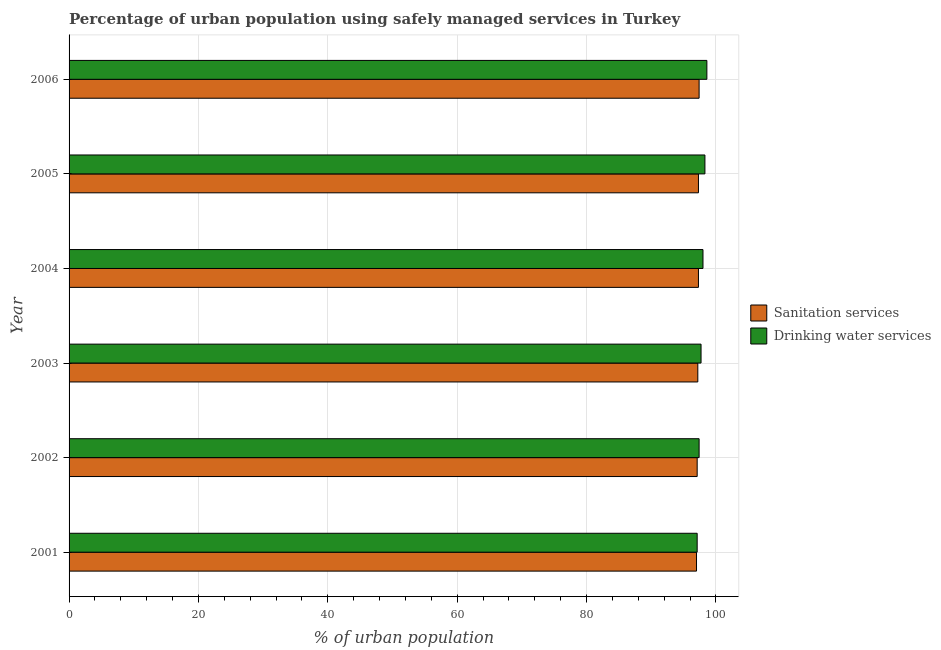How many groups of bars are there?
Offer a very short reply. 6. Are the number of bars on each tick of the Y-axis equal?
Provide a short and direct response. Yes. How many bars are there on the 3rd tick from the top?
Your response must be concise. 2. How many bars are there on the 1st tick from the bottom?
Your answer should be very brief. 2. What is the percentage of urban population who used sanitation services in 2003?
Offer a very short reply. 97.2. Across all years, what is the maximum percentage of urban population who used drinking water services?
Provide a short and direct response. 98.6. Across all years, what is the minimum percentage of urban population who used drinking water services?
Offer a very short reply. 97.1. In which year was the percentage of urban population who used drinking water services maximum?
Provide a short and direct response. 2006. What is the total percentage of urban population who used sanitation services in the graph?
Your response must be concise. 583.3. What is the difference between the percentage of urban population who used drinking water services in 2004 and the percentage of urban population who used sanitation services in 2005?
Provide a short and direct response. 0.7. What is the average percentage of urban population who used sanitation services per year?
Your answer should be very brief. 97.22. In the year 2005, what is the difference between the percentage of urban population who used drinking water services and percentage of urban population who used sanitation services?
Give a very brief answer. 1. In how many years, is the percentage of urban population who used sanitation services greater than 92 %?
Your answer should be very brief. 6. Is the percentage of urban population who used drinking water services in 2001 less than that in 2006?
Your response must be concise. Yes. What is the difference between the highest and the second highest percentage of urban population who used sanitation services?
Make the answer very short. 0.1. In how many years, is the percentage of urban population who used drinking water services greater than the average percentage of urban population who used drinking water services taken over all years?
Make the answer very short. 3. What does the 2nd bar from the top in 2001 represents?
Offer a very short reply. Sanitation services. What does the 1st bar from the bottom in 2003 represents?
Provide a short and direct response. Sanitation services. How many bars are there?
Provide a succinct answer. 12. Are all the bars in the graph horizontal?
Your answer should be compact. Yes. How many years are there in the graph?
Keep it short and to the point. 6. Are the values on the major ticks of X-axis written in scientific E-notation?
Keep it short and to the point. No. Where does the legend appear in the graph?
Your answer should be compact. Center right. How are the legend labels stacked?
Provide a succinct answer. Vertical. What is the title of the graph?
Give a very brief answer. Percentage of urban population using safely managed services in Turkey. What is the label or title of the X-axis?
Provide a succinct answer. % of urban population. What is the % of urban population of Sanitation services in 2001?
Ensure brevity in your answer.  97. What is the % of urban population of Drinking water services in 2001?
Ensure brevity in your answer.  97.1. What is the % of urban population of Sanitation services in 2002?
Your answer should be compact. 97.1. What is the % of urban population in Drinking water services in 2002?
Your answer should be compact. 97.4. What is the % of urban population of Sanitation services in 2003?
Provide a succinct answer. 97.2. What is the % of urban population of Drinking water services in 2003?
Give a very brief answer. 97.7. What is the % of urban population of Sanitation services in 2004?
Your answer should be very brief. 97.3. What is the % of urban population of Drinking water services in 2004?
Offer a terse response. 98. What is the % of urban population in Sanitation services in 2005?
Keep it short and to the point. 97.3. What is the % of urban population of Drinking water services in 2005?
Your response must be concise. 98.3. What is the % of urban population of Sanitation services in 2006?
Offer a very short reply. 97.4. What is the % of urban population of Drinking water services in 2006?
Provide a succinct answer. 98.6. Across all years, what is the maximum % of urban population in Sanitation services?
Your response must be concise. 97.4. Across all years, what is the maximum % of urban population in Drinking water services?
Give a very brief answer. 98.6. Across all years, what is the minimum % of urban population of Sanitation services?
Your response must be concise. 97. Across all years, what is the minimum % of urban population in Drinking water services?
Your answer should be compact. 97.1. What is the total % of urban population in Sanitation services in the graph?
Your answer should be very brief. 583.3. What is the total % of urban population in Drinking water services in the graph?
Offer a very short reply. 587.1. What is the difference between the % of urban population in Sanitation services in 2001 and that in 2004?
Your answer should be very brief. -0.3. What is the difference between the % of urban population in Drinking water services in 2001 and that in 2004?
Provide a short and direct response. -0.9. What is the difference between the % of urban population in Sanitation services in 2001 and that in 2005?
Provide a succinct answer. -0.3. What is the difference between the % of urban population of Drinking water services in 2001 and that in 2005?
Ensure brevity in your answer.  -1.2. What is the difference between the % of urban population of Sanitation services in 2001 and that in 2006?
Provide a succinct answer. -0.4. What is the difference between the % of urban population in Sanitation services in 2002 and that in 2003?
Your response must be concise. -0.1. What is the difference between the % of urban population in Sanitation services in 2002 and that in 2004?
Your response must be concise. -0.2. What is the difference between the % of urban population of Drinking water services in 2002 and that in 2005?
Make the answer very short. -0.9. What is the difference between the % of urban population of Sanitation services in 2002 and that in 2006?
Offer a very short reply. -0.3. What is the difference between the % of urban population of Sanitation services in 2003 and that in 2004?
Ensure brevity in your answer.  -0.1. What is the difference between the % of urban population in Drinking water services in 2003 and that in 2004?
Keep it short and to the point. -0.3. What is the difference between the % of urban population in Sanitation services in 2003 and that in 2005?
Offer a terse response. -0.1. What is the difference between the % of urban population of Drinking water services in 2003 and that in 2005?
Keep it short and to the point. -0.6. What is the difference between the % of urban population of Drinking water services in 2003 and that in 2006?
Offer a terse response. -0.9. What is the difference between the % of urban population of Sanitation services in 2004 and that in 2005?
Your response must be concise. 0. What is the difference between the % of urban population in Drinking water services in 2004 and that in 2006?
Your answer should be compact. -0.6. What is the difference between the % of urban population of Drinking water services in 2005 and that in 2006?
Offer a very short reply. -0.3. What is the difference between the % of urban population of Sanitation services in 2001 and the % of urban population of Drinking water services in 2002?
Provide a short and direct response. -0.4. What is the difference between the % of urban population of Sanitation services in 2001 and the % of urban population of Drinking water services in 2005?
Offer a terse response. -1.3. What is the difference between the % of urban population of Sanitation services in 2002 and the % of urban population of Drinking water services in 2004?
Your answer should be very brief. -0.9. What is the difference between the % of urban population of Sanitation services in 2002 and the % of urban population of Drinking water services in 2005?
Give a very brief answer. -1.2. What is the difference between the % of urban population of Sanitation services in 2002 and the % of urban population of Drinking water services in 2006?
Your answer should be very brief. -1.5. What is the difference between the % of urban population in Sanitation services in 2003 and the % of urban population in Drinking water services in 2005?
Make the answer very short. -1.1. What is the difference between the % of urban population of Sanitation services in 2004 and the % of urban population of Drinking water services in 2005?
Ensure brevity in your answer.  -1. What is the difference between the % of urban population in Sanitation services in 2004 and the % of urban population in Drinking water services in 2006?
Your answer should be very brief. -1.3. What is the average % of urban population of Sanitation services per year?
Keep it short and to the point. 97.22. What is the average % of urban population of Drinking water services per year?
Offer a terse response. 97.85. In the year 2001, what is the difference between the % of urban population of Sanitation services and % of urban population of Drinking water services?
Provide a short and direct response. -0.1. In the year 2003, what is the difference between the % of urban population in Sanitation services and % of urban population in Drinking water services?
Provide a succinct answer. -0.5. In the year 2005, what is the difference between the % of urban population in Sanitation services and % of urban population in Drinking water services?
Keep it short and to the point. -1. What is the ratio of the % of urban population of Sanitation services in 2001 to that in 2003?
Ensure brevity in your answer.  1. What is the ratio of the % of urban population of Drinking water services in 2001 to that in 2003?
Your response must be concise. 0.99. What is the ratio of the % of urban population in Sanitation services in 2001 to that in 2004?
Offer a terse response. 1. What is the ratio of the % of urban population of Sanitation services in 2001 to that in 2005?
Give a very brief answer. 1. What is the ratio of the % of urban population in Drinking water services in 2001 to that in 2006?
Ensure brevity in your answer.  0.98. What is the ratio of the % of urban population in Drinking water services in 2002 to that in 2003?
Ensure brevity in your answer.  1. What is the ratio of the % of urban population of Sanitation services in 2002 to that in 2004?
Your response must be concise. 1. What is the ratio of the % of urban population in Drinking water services in 2002 to that in 2004?
Give a very brief answer. 0.99. What is the ratio of the % of urban population in Drinking water services in 2002 to that in 2005?
Your response must be concise. 0.99. What is the ratio of the % of urban population of Sanitation services in 2002 to that in 2006?
Your response must be concise. 1. What is the ratio of the % of urban population in Drinking water services in 2002 to that in 2006?
Give a very brief answer. 0.99. What is the ratio of the % of urban population in Sanitation services in 2003 to that in 2005?
Your answer should be compact. 1. What is the ratio of the % of urban population of Drinking water services in 2003 to that in 2005?
Offer a very short reply. 0.99. What is the ratio of the % of urban population of Drinking water services in 2003 to that in 2006?
Offer a very short reply. 0.99. What is the ratio of the % of urban population of Drinking water services in 2004 to that in 2005?
Ensure brevity in your answer.  1. What is the ratio of the % of urban population in Drinking water services in 2005 to that in 2006?
Offer a very short reply. 1. What is the difference between the highest and the second highest % of urban population of Drinking water services?
Provide a succinct answer. 0.3. What is the difference between the highest and the lowest % of urban population in Drinking water services?
Give a very brief answer. 1.5. 